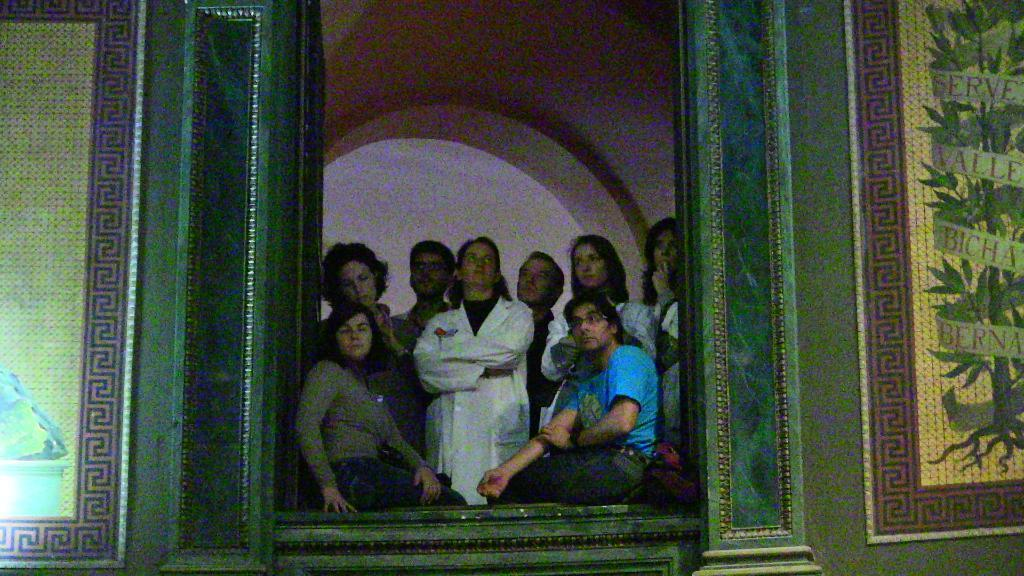How many people are present in the image? There are two people, a man and a woman, present in the image. What are the man and woman doing in the image? The man and woman are sitting in the image. Are there any other people visible in the image? Yes, there are people standing behind the man and woman. Can you describe the overall quality of the image? The image is blurry. How many cats are sitting on the chair next to the man in the image? There are no cats or chairs present in the image. What is the uncle of the man doing in the image? There is no uncle mentioned or visible in the image. 